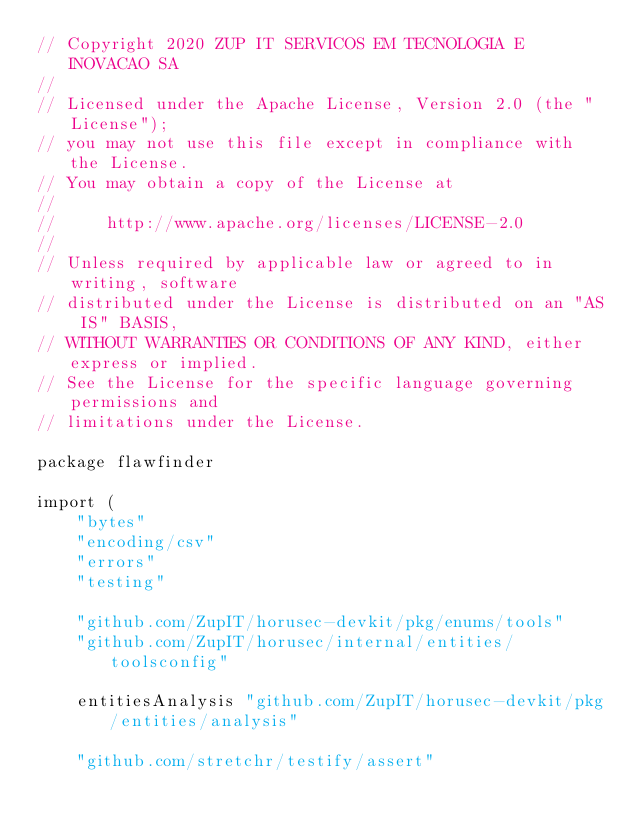Convert code to text. <code><loc_0><loc_0><loc_500><loc_500><_Go_>// Copyright 2020 ZUP IT SERVICOS EM TECNOLOGIA E INOVACAO SA
//
// Licensed under the Apache License, Version 2.0 (the "License");
// you may not use this file except in compliance with the License.
// You may obtain a copy of the License at
//
//     http://www.apache.org/licenses/LICENSE-2.0
//
// Unless required by applicable law or agreed to in writing, software
// distributed under the License is distributed on an "AS IS" BASIS,
// WITHOUT WARRANTIES OR CONDITIONS OF ANY KIND, either express or implied.
// See the License for the specific language governing permissions and
// limitations under the License.

package flawfinder

import (
	"bytes"
	"encoding/csv"
	"errors"
	"testing"

	"github.com/ZupIT/horusec-devkit/pkg/enums/tools"
	"github.com/ZupIT/horusec/internal/entities/toolsconfig"

	entitiesAnalysis "github.com/ZupIT/horusec-devkit/pkg/entities/analysis"

	"github.com/stretchr/testify/assert"
</code> 